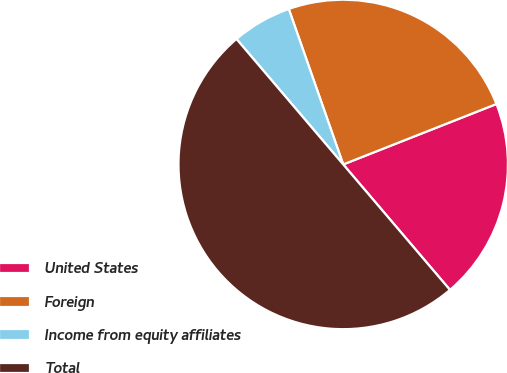<chart> <loc_0><loc_0><loc_500><loc_500><pie_chart><fcel>United States<fcel>Foreign<fcel>Income from equity affiliates<fcel>Total<nl><fcel>19.76%<fcel>24.38%<fcel>5.86%<fcel>50.0%<nl></chart> 